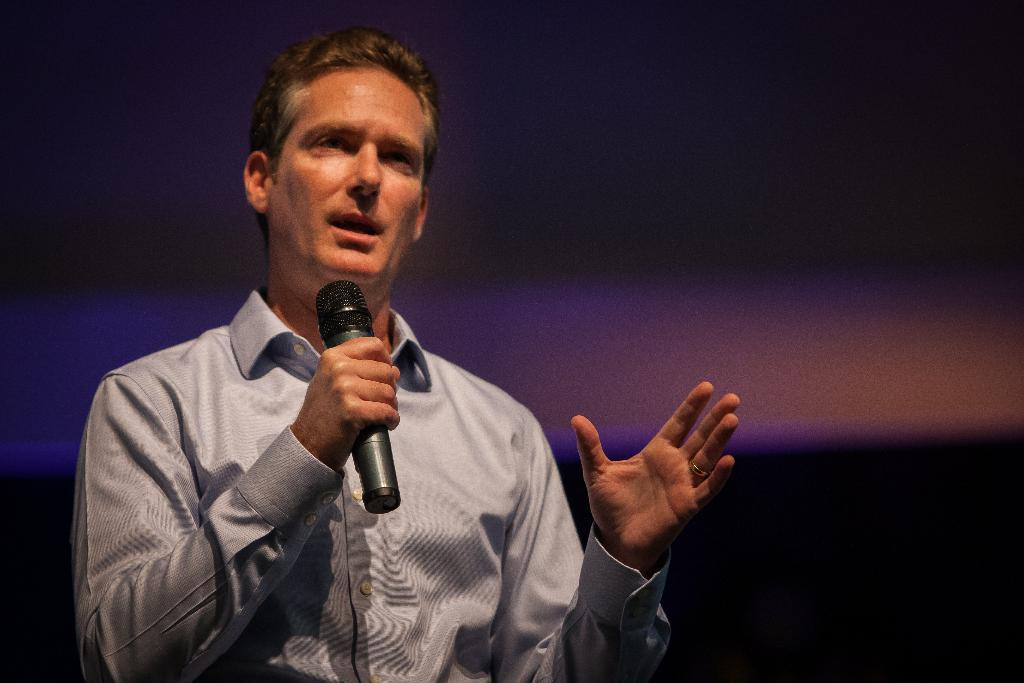Who or what is the main subject of the image? There is a person in the image. What is the person holding in the image? The person is holding a microphone. What is the person doing with the microphone? The person is speaking. Can you describe the background of the image? The background of the image is blurred. What type of picture is being exchanged between the person and the audience in the image? There is no picture being exchanged between the person and the audience in the image; the person is holding a microphone and speaking. What material is the steel used for in the image? There is no steel present in the image. 